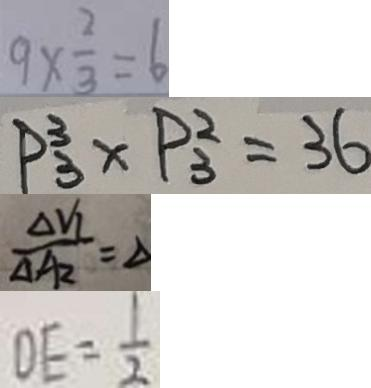<formula> <loc_0><loc_0><loc_500><loc_500>9 \times \frac { 2 } { 3 } = 6 
 P _ { 3 } ^ { 3 } \times P _ { 3 } ^ { 2 } = 3 6 
 \frac { \Delta V _ { 1 } } { \Delta A _ { 2 } } = \Delta 
 D E = \frac { 1 } { 2 }</formula> 